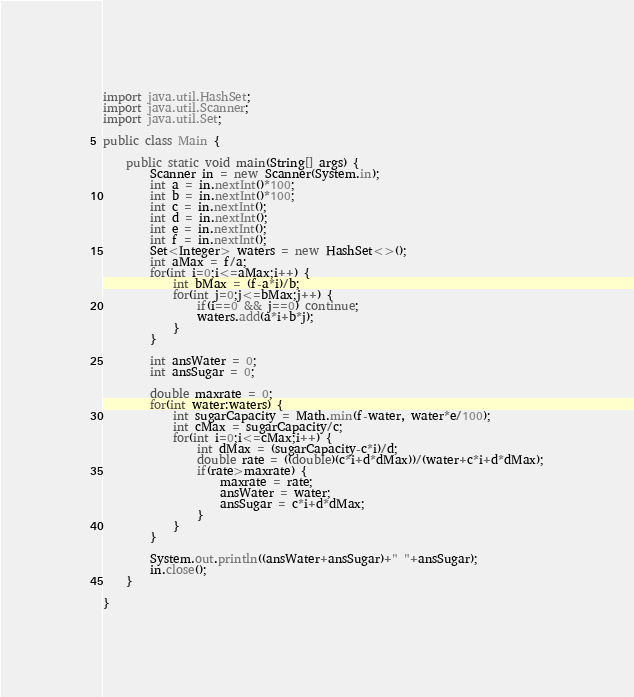Convert code to text. <code><loc_0><loc_0><loc_500><loc_500><_Java_>import java.util.HashSet;
import java.util.Scanner;
import java.util.Set;

public class Main {

	public static void main(String[] args) {
		Scanner in = new Scanner(System.in);
		int a = in.nextInt()*100;
		int b = in.nextInt()*100;
		int c = in.nextInt();
		int d = in.nextInt();
		int e = in.nextInt();
		int f = in.nextInt();
		Set<Integer> waters = new HashSet<>();
		int aMax = f/a;
		for(int i=0;i<=aMax;i++) {
			int bMax = (f-a*i)/b;
			for(int j=0;j<=bMax;j++) {
				if(i==0 && j==0) continue;
				waters.add(a*i+b*j);
			}
		}
		
		int ansWater = 0;
		int ansSugar = 0;
		
		double maxrate = 0;
		for(int water:waters) {
			int sugarCapacity = Math.min(f-water, water*e/100);
			int cMax = sugarCapacity/c;
			for(int i=0;i<=cMax;i++) {
				int dMax = (sugarCapacity-c*i)/d;
				double rate = ((double)(c*i+d*dMax))/(water+c*i+d*dMax);
				if(rate>maxrate) {
					maxrate = rate;
					ansWater = water;
					ansSugar = c*i+d*dMax;
				}
			}
		}
		
		System.out.println((ansWater+ansSugar)+" "+ansSugar);
		in.close();
	}

}
</code> 